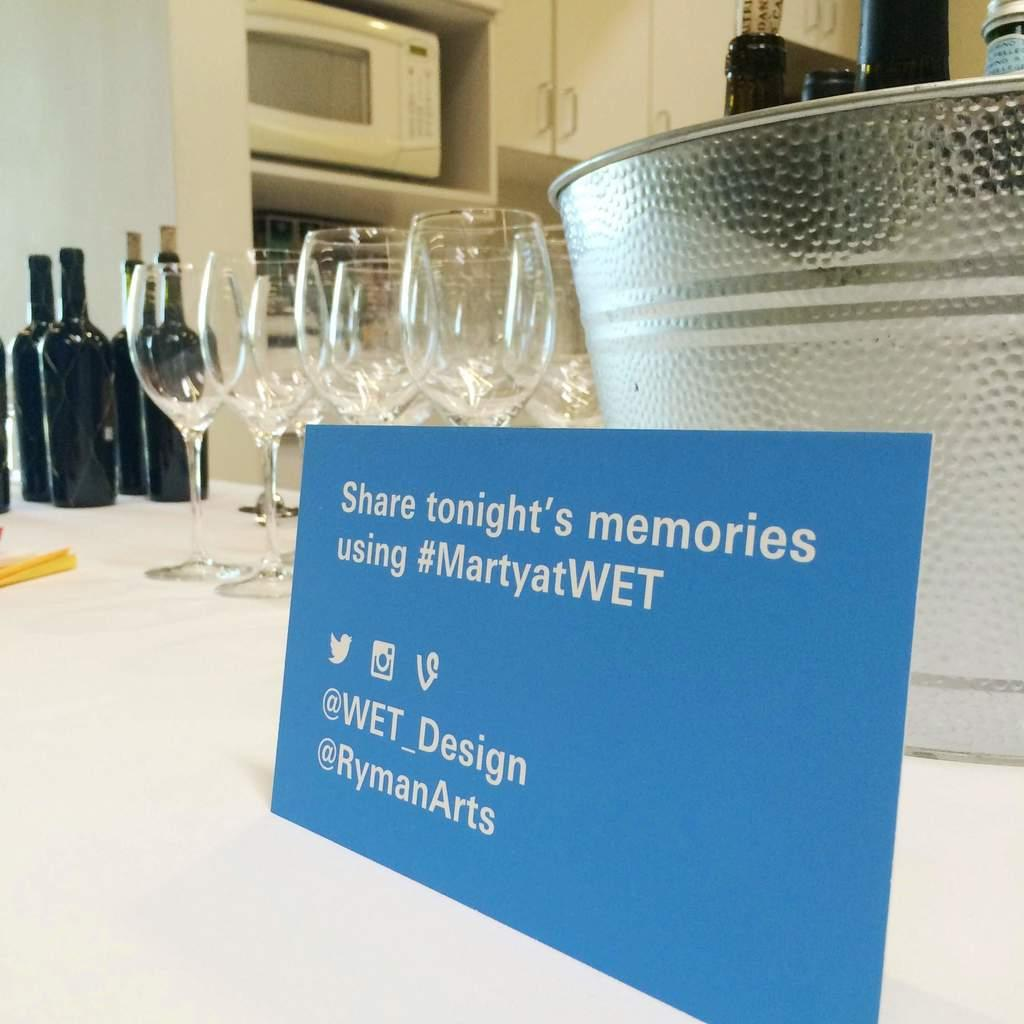<image>
Give a short and clear explanation of the subsequent image. Several wine glasses and wine bottles with a sign in front of an ice bucket advertising #MartyatWET. 